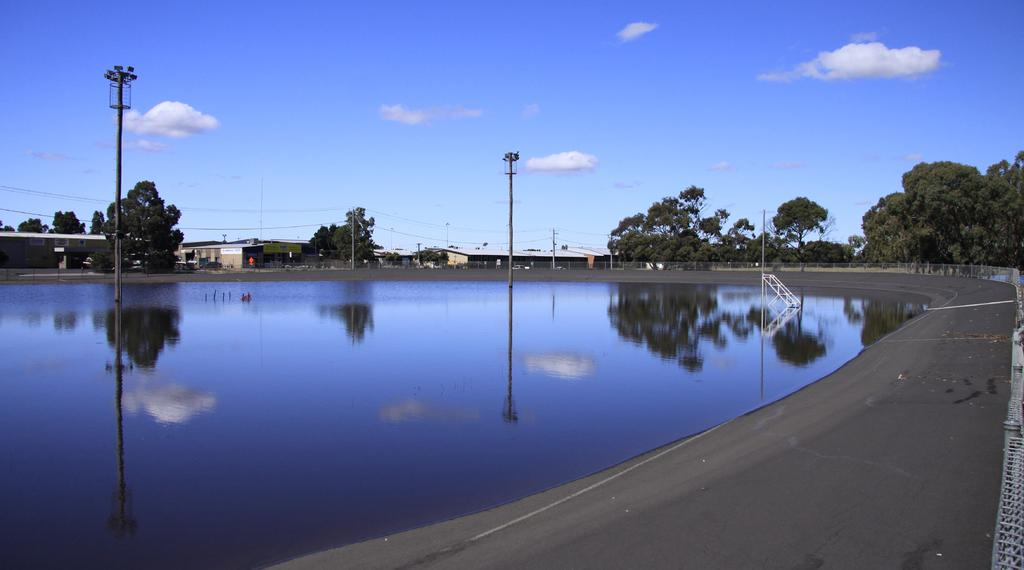What is in the foreground of the image? There is a pavement in the foreground of the image. What can be seen in the image besides the pavement? There is a railing, water, poles, buildings, trees, sky, and clouds visible in the image. What is the water in the image used for? The poles in the water suggest that it might be a body of water used for some purpose, such as a dock or a mooring area. What is visible in the background of the image? There are buildings, trees, and sky visible in the background of the image. What can be seen in the sky in the image? There are clouds visible in the sky. Where is the notebook located in the image? There is no notebook present in the image. What type of parent is depicted in the image? There is no parent depicted in the image. 